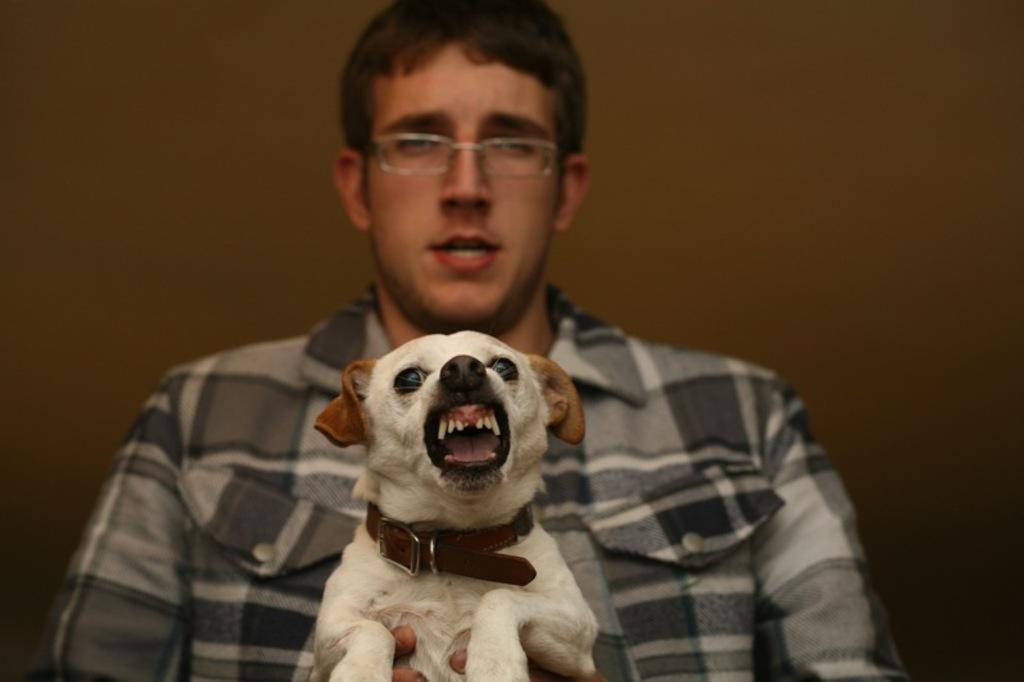What is the main subject of the image? There is a person in the image. What is the person doing in the image? The person is holding a dog. Can you describe the dog's appearance in the image? The dog has a belt around its neck. What type of memory does the person have in the image? There is no mention of a memory in the image; it features a person holding a dog with a belt around its neck. 